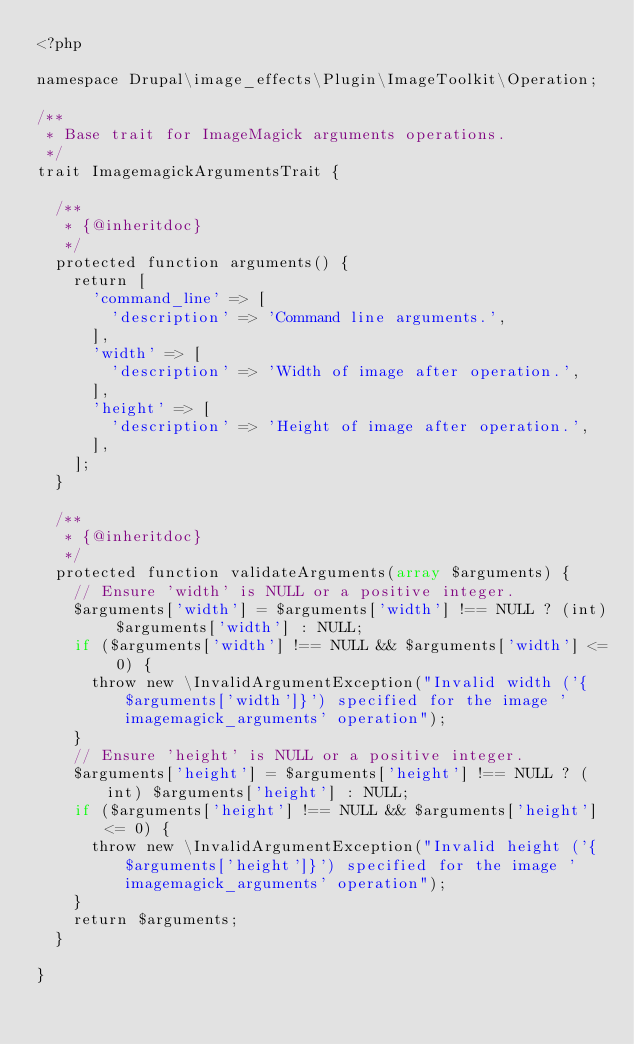<code> <loc_0><loc_0><loc_500><loc_500><_PHP_><?php

namespace Drupal\image_effects\Plugin\ImageToolkit\Operation;

/**
 * Base trait for ImageMagick arguments operations.
 */
trait ImagemagickArgumentsTrait {

  /**
   * {@inheritdoc}
   */
  protected function arguments() {
    return [
      'command_line' => [
        'description' => 'Command line arguments.',
      ],
      'width' => [
        'description' => 'Width of image after operation.',
      ],
      'height' => [
        'description' => 'Height of image after operation.',
      ],
    ];
  }

  /**
   * {@inheritdoc}
   */
  protected function validateArguments(array $arguments) {
    // Ensure 'width' is NULL or a positive integer.
    $arguments['width'] = $arguments['width'] !== NULL ? (int) $arguments['width'] : NULL;
    if ($arguments['width'] !== NULL && $arguments['width'] <= 0) {
      throw new \InvalidArgumentException("Invalid width ('{$arguments['width']}') specified for the image 'imagemagick_arguments' operation");
    }
    // Ensure 'height' is NULL or a positive integer.
    $arguments['height'] = $arguments['height'] !== NULL ? (int) $arguments['height'] : NULL;
    if ($arguments['height'] !== NULL && $arguments['height'] <= 0) {
      throw new \InvalidArgumentException("Invalid height ('{$arguments['height']}') specified for the image 'imagemagick_arguments' operation");
    }
    return $arguments;
  }

}
</code> 